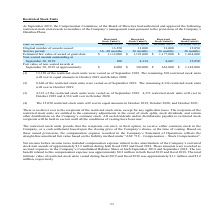From Amcon Distributing's financial document, How many restricted stock units awarded in October 2015 and 2016 were vested respectively as of September 2019? The document shows two values: 13,150 and 8,666. From the document: "(1) 13,150 of the restricted stock units were vested as of September 2019. The remaining 100 restricted stock (2) 8,666 of the restricted stock units ..." Also, How many restricted stock units awarded in October 2017 were vested as of September 2019? According to the financial document, 4,333. The relevant text states: "(3) 4,333 of the restricted stock units were vested as of September 2019. 4,333 restricted stock units will v (3) 4,333 of the restricted stock units were vested as of September 2019. 4,333 restricted..." Also, What is the total intrinsic value of restricted stock units vested during fiscal 2019 and fiscal 2018 respectively? The document shows two values: $1.1 million and $1.2 million. From the document: "ny’s restricted stock unit awards of approximately $1.2 million during both fiscal 2019 and fiscal 2018. These amounts were recorded as accrued expens..." Also, can you calculate: What is the percentage change in the number of restricted stock units originally issued in October 2015 and 2016? To answer this question, I need to perform calculations using the financial data. The calculation is: (13,000 -13,250)/13,250 , which equals -1.89 (percentage). This is based on the information: "Original number of awards issued: 13,250 13,000 13,000 15,050 Original number of awards issued: 13,250 13,000 13,000 15,050..." The key data points involved are: 13,000, 13,250. Also, can you calculate: What is the percentage change in the number of restricted stock units originally issued in October 2017 and 2018? To answer this question, I need to perform calculations using the financial data. The calculation is: (15,050 - 13,000)/13,000 , which equals 15.77 (percentage). This is based on the information: "nal number of awards issued: 13,250 13,000 13,000 15,050 Original number of awards issued: 13,250 13,000 13,000 15,050..." The key data points involved are: 13,000, 15,050. Also, can you calculate: What is the total number of restricted stock units vested as of September 2019? Based on the calculation: (13,150 + 8,666 + 4,333), the result is 26149. This is based on the information: "(1) 13,150 of the restricted stock units were vested as of September 2019. The remaining 100 restricted stock (2) 8,666 of the restricted stock units were vested as of September 2019. The remaining 4,..." The key data points involved are: 13,150, 4,333, 8,666. 